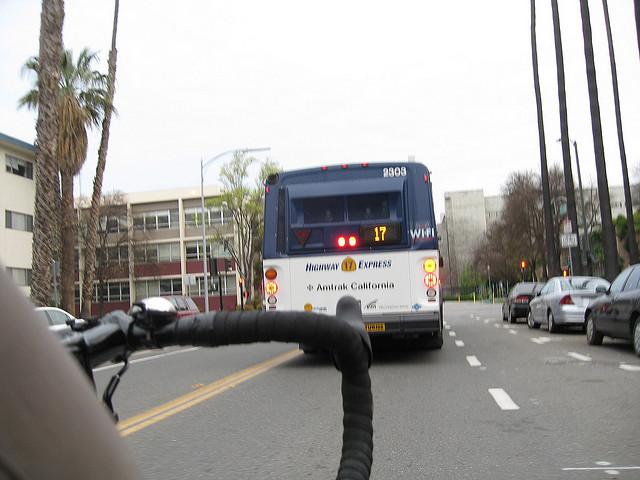What is the number on the bus?
Concise answer only. 17. How many cars are parked on the right side of the road?
Be succinct. 3. How many stories are in the building with red?
Answer briefly. 3. What company owns the black truck?
Be succinct. Highway express. 